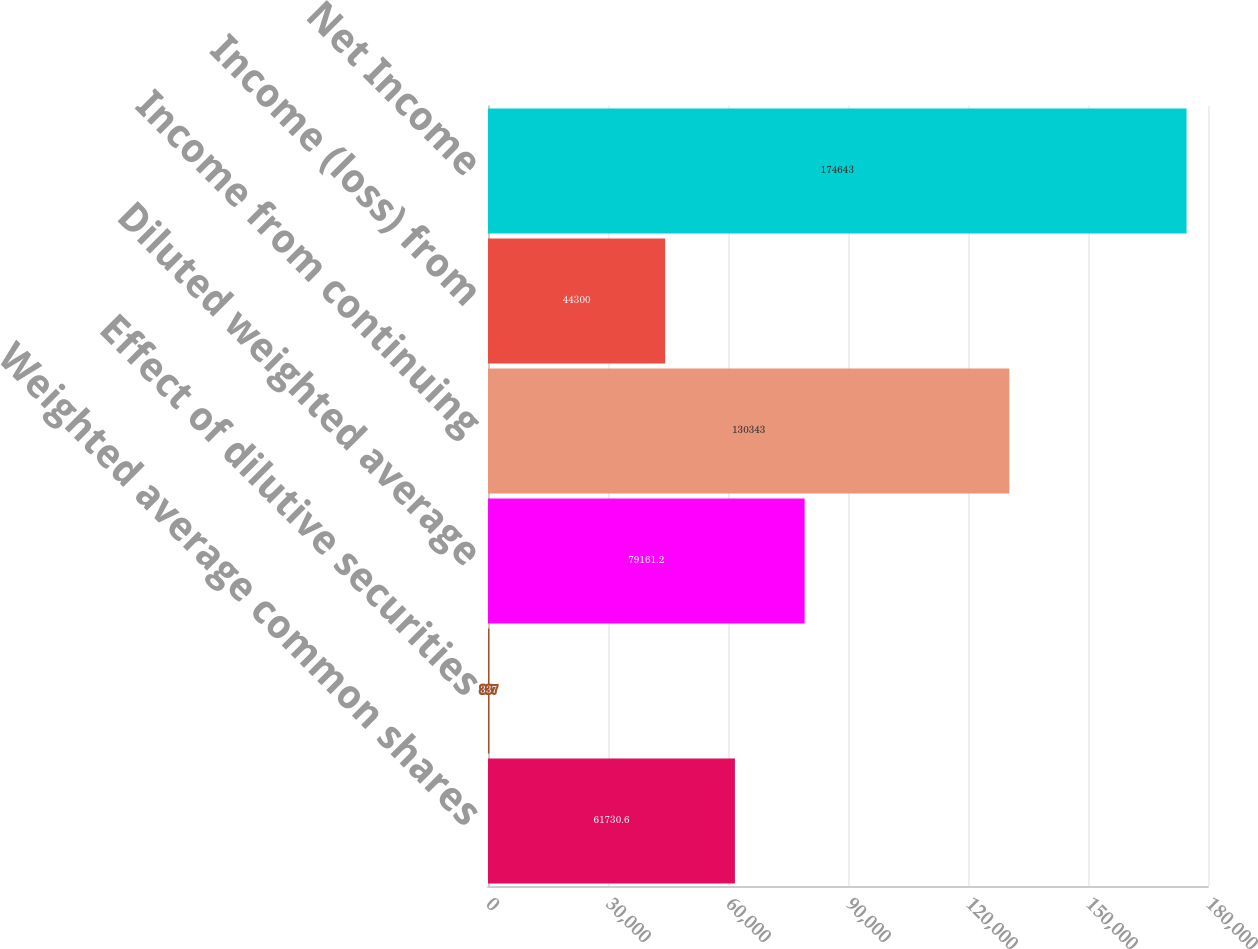<chart> <loc_0><loc_0><loc_500><loc_500><bar_chart><fcel>Weighted average common shares<fcel>Effect of dilutive securities<fcel>Diluted weighted average<fcel>Income from continuing<fcel>Income (loss) from<fcel>Net Income<nl><fcel>61730.6<fcel>337<fcel>79161.2<fcel>130343<fcel>44300<fcel>174643<nl></chart> 